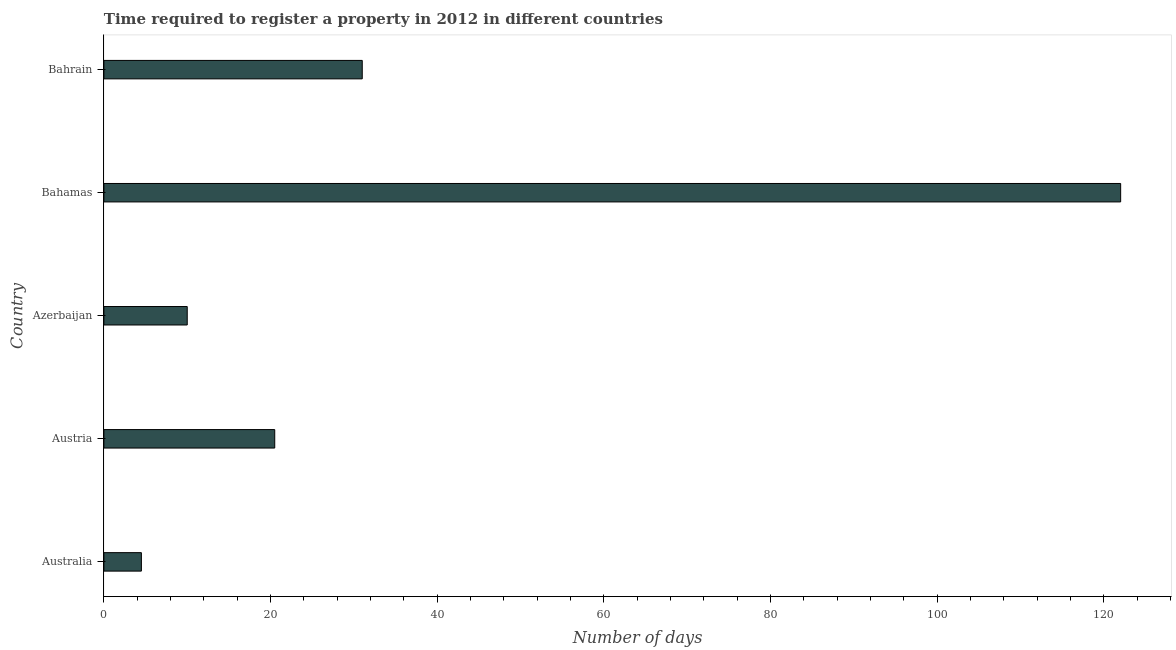Does the graph contain any zero values?
Keep it short and to the point. No. What is the title of the graph?
Your answer should be very brief. Time required to register a property in 2012 in different countries. What is the label or title of the X-axis?
Keep it short and to the point. Number of days. What is the number of days required to register property in Bahamas?
Offer a terse response. 122. Across all countries, what is the maximum number of days required to register property?
Your response must be concise. 122. Across all countries, what is the minimum number of days required to register property?
Offer a terse response. 4.5. In which country was the number of days required to register property maximum?
Ensure brevity in your answer.  Bahamas. What is the sum of the number of days required to register property?
Offer a very short reply. 188. What is the difference between the number of days required to register property in Azerbaijan and Bahamas?
Your answer should be compact. -112. What is the average number of days required to register property per country?
Your answer should be very brief. 37.6. What is the ratio of the number of days required to register property in Austria to that in Azerbaijan?
Offer a very short reply. 2.05. Is the number of days required to register property in Bahamas less than that in Bahrain?
Give a very brief answer. No. What is the difference between the highest and the second highest number of days required to register property?
Make the answer very short. 91. What is the difference between the highest and the lowest number of days required to register property?
Your response must be concise. 117.5. In how many countries, is the number of days required to register property greater than the average number of days required to register property taken over all countries?
Offer a very short reply. 1. What is the Number of days of Austria?
Your answer should be compact. 20.5. What is the Number of days in Bahamas?
Ensure brevity in your answer.  122. What is the Number of days in Bahrain?
Offer a very short reply. 31. What is the difference between the Number of days in Australia and Bahamas?
Your answer should be compact. -117.5. What is the difference between the Number of days in Australia and Bahrain?
Your response must be concise. -26.5. What is the difference between the Number of days in Austria and Bahamas?
Offer a very short reply. -101.5. What is the difference between the Number of days in Austria and Bahrain?
Provide a short and direct response. -10.5. What is the difference between the Number of days in Azerbaijan and Bahamas?
Your answer should be compact. -112. What is the difference between the Number of days in Azerbaijan and Bahrain?
Ensure brevity in your answer.  -21. What is the difference between the Number of days in Bahamas and Bahrain?
Make the answer very short. 91. What is the ratio of the Number of days in Australia to that in Austria?
Offer a terse response. 0.22. What is the ratio of the Number of days in Australia to that in Azerbaijan?
Keep it short and to the point. 0.45. What is the ratio of the Number of days in Australia to that in Bahamas?
Your answer should be very brief. 0.04. What is the ratio of the Number of days in Australia to that in Bahrain?
Offer a very short reply. 0.14. What is the ratio of the Number of days in Austria to that in Azerbaijan?
Offer a very short reply. 2.05. What is the ratio of the Number of days in Austria to that in Bahamas?
Give a very brief answer. 0.17. What is the ratio of the Number of days in Austria to that in Bahrain?
Your answer should be compact. 0.66. What is the ratio of the Number of days in Azerbaijan to that in Bahamas?
Offer a very short reply. 0.08. What is the ratio of the Number of days in Azerbaijan to that in Bahrain?
Offer a very short reply. 0.32. What is the ratio of the Number of days in Bahamas to that in Bahrain?
Give a very brief answer. 3.94. 